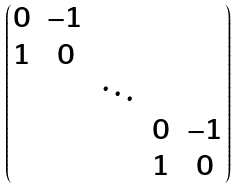Convert formula to latex. <formula><loc_0><loc_0><loc_500><loc_500>\begin{pmatrix} 0 & - 1 & & & \\ 1 & 0 & & & \\ & & \ddots & & \\ & & & 0 & - 1 \\ & & & 1 & 0 \end{pmatrix}</formula> 